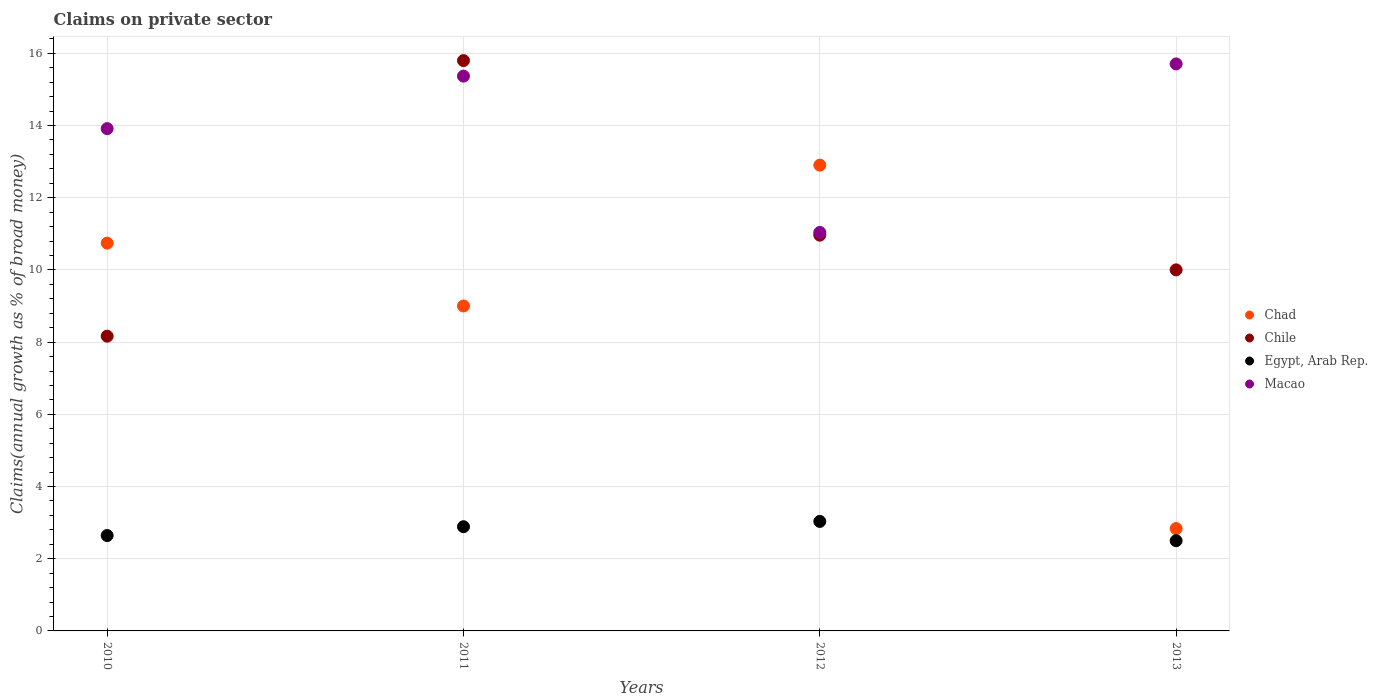Is the number of dotlines equal to the number of legend labels?
Make the answer very short. Yes. What is the percentage of broad money claimed on private sector in Chile in 2013?
Your answer should be compact. 10. Across all years, what is the maximum percentage of broad money claimed on private sector in Egypt, Arab Rep.?
Keep it short and to the point. 3.03. Across all years, what is the minimum percentage of broad money claimed on private sector in Egypt, Arab Rep.?
Your answer should be compact. 2.5. In which year was the percentage of broad money claimed on private sector in Chile maximum?
Provide a succinct answer. 2011. What is the total percentage of broad money claimed on private sector in Egypt, Arab Rep. in the graph?
Your response must be concise. 11.06. What is the difference between the percentage of broad money claimed on private sector in Macao in 2010 and that in 2013?
Ensure brevity in your answer.  -1.79. What is the difference between the percentage of broad money claimed on private sector in Chad in 2011 and the percentage of broad money claimed on private sector in Egypt, Arab Rep. in 2012?
Ensure brevity in your answer.  5.97. What is the average percentage of broad money claimed on private sector in Egypt, Arab Rep. per year?
Ensure brevity in your answer.  2.77. In the year 2013, what is the difference between the percentage of broad money claimed on private sector in Egypt, Arab Rep. and percentage of broad money claimed on private sector in Macao?
Your response must be concise. -13.21. In how many years, is the percentage of broad money claimed on private sector in Chile greater than 0.8 %?
Keep it short and to the point. 4. What is the ratio of the percentage of broad money claimed on private sector in Egypt, Arab Rep. in 2010 to that in 2011?
Your answer should be very brief. 0.92. What is the difference between the highest and the second highest percentage of broad money claimed on private sector in Egypt, Arab Rep.?
Offer a very short reply. 0.15. What is the difference between the highest and the lowest percentage of broad money claimed on private sector in Chile?
Make the answer very short. 7.63. In how many years, is the percentage of broad money claimed on private sector in Egypt, Arab Rep. greater than the average percentage of broad money claimed on private sector in Egypt, Arab Rep. taken over all years?
Offer a terse response. 2. Is it the case that in every year, the sum of the percentage of broad money claimed on private sector in Chad and percentage of broad money claimed on private sector in Macao  is greater than the sum of percentage of broad money claimed on private sector in Egypt, Arab Rep. and percentage of broad money claimed on private sector in Chile?
Offer a very short reply. No. Is the percentage of broad money claimed on private sector in Chile strictly greater than the percentage of broad money claimed on private sector in Egypt, Arab Rep. over the years?
Provide a short and direct response. Yes. Is the percentage of broad money claimed on private sector in Chad strictly less than the percentage of broad money claimed on private sector in Chile over the years?
Make the answer very short. No. How many dotlines are there?
Make the answer very short. 4. How many years are there in the graph?
Provide a short and direct response. 4. Are the values on the major ticks of Y-axis written in scientific E-notation?
Provide a short and direct response. No. How many legend labels are there?
Offer a very short reply. 4. How are the legend labels stacked?
Offer a terse response. Vertical. What is the title of the graph?
Your answer should be compact. Claims on private sector. Does "Comoros" appear as one of the legend labels in the graph?
Offer a terse response. No. What is the label or title of the X-axis?
Provide a short and direct response. Years. What is the label or title of the Y-axis?
Your response must be concise. Claims(annual growth as % of broad money). What is the Claims(annual growth as % of broad money) of Chad in 2010?
Offer a terse response. 10.74. What is the Claims(annual growth as % of broad money) of Chile in 2010?
Offer a very short reply. 8.16. What is the Claims(annual growth as % of broad money) in Egypt, Arab Rep. in 2010?
Offer a terse response. 2.64. What is the Claims(annual growth as % of broad money) in Macao in 2010?
Provide a short and direct response. 13.91. What is the Claims(annual growth as % of broad money) in Chad in 2011?
Offer a very short reply. 9. What is the Claims(annual growth as % of broad money) in Chile in 2011?
Ensure brevity in your answer.  15.8. What is the Claims(annual growth as % of broad money) of Egypt, Arab Rep. in 2011?
Your response must be concise. 2.89. What is the Claims(annual growth as % of broad money) in Macao in 2011?
Offer a terse response. 15.37. What is the Claims(annual growth as % of broad money) of Chad in 2012?
Your answer should be very brief. 12.9. What is the Claims(annual growth as % of broad money) in Chile in 2012?
Keep it short and to the point. 10.96. What is the Claims(annual growth as % of broad money) of Egypt, Arab Rep. in 2012?
Provide a short and direct response. 3.03. What is the Claims(annual growth as % of broad money) of Macao in 2012?
Provide a succinct answer. 11.04. What is the Claims(annual growth as % of broad money) of Chad in 2013?
Your answer should be compact. 2.84. What is the Claims(annual growth as % of broad money) in Chile in 2013?
Ensure brevity in your answer.  10. What is the Claims(annual growth as % of broad money) in Egypt, Arab Rep. in 2013?
Offer a very short reply. 2.5. What is the Claims(annual growth as % of broad money) of Macao in 2013?
Provide a short and direct response. 15.71. Across all years, what is the maximum Claims(annual growth as % of broad money) in Chad?
Provide a short and direct response. 12.9. Across all years, what is the maximum Claims(annual growth as % of broad money) of Chile?
Your answer should be very brief. 15.8. Across all years, what is the maximum Claims(annual growth as % of broad money) of Egypt, Arab Rep.?
Ensure brevity in your answer.  3.03. Across all years, what is the maximum Claims(annual growth as % of broad money) in Macao?
Provide a short and direct response. 15.71. Across all years, what is the minimum Claims(annual growth as % of broad money) in Chad?
Offer a very short reply. 2.84. Across all years, what is the minimum Claims(annual growth as % of broad money) in Chile?
Make the answer very short. 8.16. Across all years, what is the minimum Claims(annual growth as % of broad money) in Egypt, Arab Rep.?
Give a very brief answer. 2.5. Across all years, what is the minimum Claims(annual growth as % of broad money) in Macao?
Your response must be concise. 11.04. What is the total Claims(annual growth as % of broad money) of Chad in the graph?
Keep it short and to the point. 35.48. What is the total Claims(annual growth as % of broad money) of Chile in the graph?
Provide a succinct answer. 44.93. What is the total Claims(annual growth as % of broad money) in Egypt, Arab Rep. in the graph?
Provide a short and direct response. 11.06. What is the total Claims(annual growth as % of broad money) in Macao in the graph?
Ensure brevity in your answer.  56.03. What is the difference between the Claims(annual growth as % of broad money) of Chad in 2010 and that in 2011?
Your answer should be compact. 1.74. What is the difference between the Claims(annual growth as % of broad money) in Chile in 2010 and that in 2011?
Ensure brevity in your answer.  -7.63. What is the difference between the Claims(annual growth as % of broad money) of Egypt, Arab Rep. in 2010 and that in 2011?
Give a very brief answer. -0.24. What is the difference between the Claims(annual growth as % of broad money) of Macao in 2010 and that in 2011?
Ensure brevity in your answer.  -1.45. What is the difference between the Claims(annual growth as % of broad money) in Chad in 2010 and that in 2012?
Provide a short and direct response. -2.16. What is the difference between the Claims(annual growth as % of broad money) of Chile in 2010 and that in 2012?
Provide a short and direct response. -2.8. What is the difference between the Claims(annual growth as % of broad money) in Egypt, Arab Rep. in 2010 and that in 2012?
Provide a succinct answer. -0.39. What is the difference between the Claims(annual growth as % of broad money) in Macao in 2010 and that in 2012?
Your answer should be compact. 2.88. What is the difference between the Claims(annual growth as % of broad money) of Chad in 2010 and that in 2013?
Provide a short and direct response. 7.91. What is the difference between the Claims(annual growth as % of broad money) in Chile in 2010 and that in 2013?
Your answer should be compact. -1.84. What is the difference between the Claims(annual growth as % of broad money) in Egypt, Arab Rep. in 2010 and that in 2013?
Your answer should be compact. 0.14. What is the difference between the Claims(annual growth as % of broad money) in Macao in 2010 and that in 2013?
Offer a very short reply. -1.79. What is the difference between the Claims(annual growth as % of broad money) of Chad in 2011 and that in 2012?
Provide a short and direct response. -3.9. What is the difference between the Claims(annual growth as % of broad money) of Chile in 2011 and that in 2012?
Give a very brief answer. 4.84. What is the difference between the Claims(annual growth as % of broad money) of Egypt, Arab Rep. in 2011 and that in 2012?
Provide a short and direct response. -0.15. What is the difference between the Claims(annual growth as % of broad money) of Macao in 2011 and that in 2012?
Give a very brief answer. 4.33. What is the difference between the Claims(annual growth as % of broad money) in Chad in 2011 and that in 2013?
Offer a terse response. 6.17. What is the difference between the Claims(annual growth as % of broad money) in Chile in 2011 and that in 2013?
Your response must be concise. 5.8. What is the difference between the Claims(annual growth as % of broad money) in Egypt, Arab Rep. in 2011 and that in 2013?
Ensure brevity in your answer.  0.39. What is the difference between the Claims(annual growth as % of broad money) of Macao in 2011 and that in 2013?
Provide a short and direct response. -0.34. What is the difference between the Claims(annual growth as % of broad money) of Chad in 2012 and that in 2013?
Give a very brief answer. 10.07. What is the difference between the Claims(annual growth as % of broad money) of Chile in 2012 and that in 2013?
Offer a very short reply. 0.96. What is the difference between the Claims(annual growth as % of broad money) in Egypt, Arab Rep. in 2012 and that in 2013?
Your answer should be compact. 0.53. What is the difference between the Claims(annual growth as % of broad money) in Macao in 2012 and that in 2013?
Give a very brief answer. -4.67. What is the difference between the Claims(annual growth as % of broad money) in Chad in 2010 and the Claims(annual growth as % of broad money) in Chile in 2011?
Ensure brevity in your answer.  -5.06. What is the difference between the Claims(annual growth as % of broad money) of Chad in 2010 and the Claims(annual growth as % of broad money) of Egypt, Arab Rep. in 2011?
Your response must be concise. 7.86. What is the difference between the Claims(annual growth as % of broad money) in Chad in 2010 and the Claims(annual growth as % of broad money) in Macao in 2011?
Your answer should be very brief. -4.63. What is the difference between the Claims(annual growth as % of broad money) of Chile in 2010 and the Claims(annual growth as % of broad money) of Egypt, Arab Rep. in 2011?
Offer a terse response. 5.28. What is the difference between the Claims(annual growth as % of broad money) in Chile in 2010 and the Claims(annual growth as % of broad money) in Macao in 2011?
Your answer should be very brief. -7.2. What is the difference between the Claims(annual growth as % of broad money) of Egypt, Arab Rep. in 2010 and the Claims(annual growth as % of broad money) of Macao in 2011?
Your answer should be compact. -12.73. What is the difference between the Claims(annual growth as % of broad money) in Chad in 2010 and the Claims(annual growth as % of broad money) in Chile in 2012?
Give a very brief answer. -0.22. What is the difference between the Claims(annual growth as % of broad money) in Chad in 2010 and the Claims(annual growth as % of broad money) in Egypt, Arab Rep. in 2012?
Your answer should be compact. 7.71. What is the difference between the Claims(annual growth as % of broad money) of Chad in 2010 and the Claims(annual growth as % of broad money) of Macao in 2012?
Provide a short and direct response. -0.3. What is the difference between the Claims(annual growth as % of broad money) in Chile in 2010 and the Claims(annual growth as % of broad money) in Egypt, Arab Rep. in 2012?
Offer a very short reply. 5.13. What is the difference between the Claims(annual growth as % of broad money) in Chile in 2010 and the Claims(annual growth as % of broad money) in Macao in 2012?
Offer a very short reply. -2.87. What is the difference between the Claims(annual growth as % of broad money) in Egypt, Arab Rep. in 2010 and the Claims(annual growth as % of broad money) in Macao in 2012?
Provide a short and direct response. -8.4. What is the difference between the Claims(annual growth as % of broad money) of Chad in 2010 and the Claims(annual growth as % of broad money) of Chile in 2013?
Keep it short and to the point. 0.74. What is the difference between the Claims(annual growth as % of broad money) in Chad in 2010 and the Claims(annual growth as % of broad money) in Egypt, Arab Rep. in 2013?
Keep it short and to the point. 8.24. What is the difference between the Claims(annual growth as % of broad money) in Chad in 2010 and the Claims(annual growth as % of broad money) in Macao in 2013?
Keep it short and to the point. -4.96. What is the difference between the Claims(annual growth as % of broad money) of Chile in 2010 and the Claims(annual growth as % of broad money) of Egypt, Arab Rep. in 2013?
Keep it short and to the point. 5.67. What is the difference between the Claims(annual growth as % of broad money) of Chile in 2010 and the Claims(annual growth as % of broad money) of Macao in 2013?
Offer a terse response. -7.54. What is the difference between the Claims(annual growth as % of broad money) in Egypt, Arab Rep. in 2010 and the Claims(annual growth as % of broad money) in Macao in 2013?
Your answer should be very brief. -13.06. What is the difference between the Claims(annual growth as % of broad money) of Chad in 2011 and the Claims(annual growth as % of broad money) of Chile in 2012?
Offer a terse response. -1.96. What is the difference between the Claims(annual growth as % of broad money) in Chad in 2011 and the Claims(annual growth as % of broad money) in Egypt, Arab Rep. in 2012?
Make the answer very short. 5.97. What is the difference between the Claims(annual growth as % of broad money) in Chad in 2011 and the Claims(annual growth as % of broad money) in Macao in 2012?
Your response must be concise. -2.04. What is the difference between the Claims(annual growth as % of broad money) in Chile in 2011 and the Claims(annual growth as % of broad money) in Egypt, Arab Rep. in 2012?
Offer a terse response. 12.77. What is the difference between the Claims(annual growth as % of broad money) of Chile in 2011 and the Claims(annual growth as % of broad money) of Macao in 2012?
Give a very brief answer. 4.76. What is the difference between the Claims(annual growth as % of broad money) of Egypt, Arab Rep. in 2011 and the Claims(annual growth as % of broad money) of Macao in 2012?
Offer a terse response. -8.15. What is the difference between the Claims(annual growth as % of broad money) of Chad in 2011 and the Claims(annual growth as % of broad money) of Chile in 2013?
Your answer should be very brief. -1. What is the difference between the Claims(annual growth as % of broad money) in Chad in 2011 and the Claims(annual growth as % of broad money) in Egypt, Arab Rep. in 2013?
Provide a succinct answer. 6.5. What is the difference between the Claims(annual growth as % of broad money) in Chad in 2011 and the Claims(annual growth as % of broad money) in Macao in 2013?
Keep it short and to the point. -6.71. What is the difference between the Claims(annual growth as % of broad money) in Chile in 2011 and the Claims(annual growth as % of broad money) in Egypt, Arab Rep. in 2013?
Make the answer very short. 13.3. What is the difference between the Claims(annual growth as % of broad money) in Chile in 2011 and the Claims(annual growth as % of broad money) in Macao in 2013?
Your answer should be compact. 0.09. What is the difference between the Claims(annual growth as % of broad money) in Egypt, Arab Rep. in 2011 and the Claims(annual growth as % of broad money) in Macao in 2013?
Keep it short and to the point. -12.82. What is the difference between the Claims(annual growth as % of broad money) of Chad in 2012 and the Claims(annual growth as % of broad money) of Chile in 2013?
Your answer should be very brief. 2.9. What is the difference between the Claims(annual growth as % of broad money) in Chad in 2012 and the Claims(annual growth as % of broad money) in Egypt, Arab Rep. in 2013?
Keep it short and to the point. 10.4. What is the difference between the Claims(annual growth as % of broad money) in Chad in 2012 and the Claims(annual growth as % of broad money) in Macao in 2013?
Make the answer very short. -2.8. What is the difference between the Claims(annual growth as % of broad money) in Chile in 2012 and the Claims(annual growth as % of broad money) in Egypt, Arab Rep. in 2013?
Your answer should be compact. 8.46. What is the difference between the Claims(annual growth as % of broad money) of Chile in 2012 and the Claims(annual growth as % of broad money) of Macao in 2013?
Ensure brevity in your answer.  -4.74. What is the difference between the Claims(annual growth as % of broad money) in Egypt, Arab Rep. in 2012 and the Claims(annual growth as % of broad money) in Macao in 2013?
Offer a very short reply. -12.67. What is the average Claims(annual growth as % of broad money) in Chad per year?
Provide a succinct answer. 8.87. What is the average Claims(annual growth as % of broad money) of Chile per year?
Ensure brevity in your answer.  11.23. What is the average Claims(annual growth as % of broad money) of Egypt, Arab Rep. per year?
Ensure brevity in your answer.  2.77. What is the average Claims(annual growth as % of broad money) in Macao per year?
Your answer should be compact. 14.01. In the year 2010, what is the difference between the Claims(annual growth as % of broad money) in Chad and Claims(annual growth as % of broad money) in Chile?
Provide a short and direct response. 2.58. In the year 2010, what is the difference between the Claims(annual growth as % of broad money) in Chad and Claims(annual growth as % of broad money) in Egypt, Arab Rep.?
Your answer should be very brief. 8.1. In the year 2010, what is the difference between the Claims(annual growth as % of broad money) of Chad and Claims(annual growth as % of broad money) of Macao?
Provide a succinct answer. -3.17. In the year 2010, what is the difference between the Claims(annual growth as % of broad money) in Chile and Claims(annual growth as % of broad money) in Egypt, Arab Rep.?
Offer a very short reply. 5.52. In the year 2010, what is the difference between the Claims(annual growth as % of broad money) of Chile and Claims(annual growth as % of broad money) of Macao?
Provide a succinct answer. -5.75. In the year 2010, what is the difference between the Claims(annual growth as % of broad money) of Egypt, Arab Rep. and Claims(annual growth as % of broad money) of Macao?
Provide a short and direct response. -11.27. In the year 2011, what is the difference between the Claims(annual growth as % of broad money) in Chad and Claims(annual growth as % of broad money) in Chile?
Your answer should be very brief. -6.8. In the year 2011, what is the difference between the Claims(annual growth as % of broad money) in Chad and Claims(annual growth as % of broad money) in Egypt, Arab Rep.?
Your answer should be very brief. 6.11. In the year 2011, what is the difference between the Claims(annual growth as % of broad money) of Chad and Claims(annual growth as % of broad money) of Macao?
Provide a short and direct response. -6.37. In the year 2011, what is the difference between the Claims(annual growth as % of broad money) of Chile and Claims(annual growth as % of broad money) of Egypt, Arab Rep.?
Make the answer very short. 12.91. In the year 2011, what is the difference between the Claims(annual growth as % of broad money) in Chile and Claims(annual growth as % of broad money) in Macao?
Offer a terse response. 0.43. In the year 2011, what is the difference between the Claims(annual growth as % of broad money) of Egypt, Arab Rep. and Claims(annual growth as % of broad money) of Macao?
Keep it short and to the point. -12.48. In the year 2012, what is the difference between the Claims(annual growth as % of broad money) in Chad and Claims(annual growth as % of broad money) in Chile?
Provide a succinct answer. 1.94. In the year 2012, what is the difference between the Claims(annual growth as % of broad money) in Chad and Claims(annual growth as % of broad money) in Egypt, Arab Rep.?
Your answer should be very brief. 9.87. In the year 2012, what is the difference between the Claims(annual growth as % of broad money) in Chad and Claims(annual growth as % of broad money) in Macao?
Keep it short and to the point. 1.86. In the year 2012, what is the difference between the Claims(annual growth as % of broad money) of Chile and Claims(annual growth as % of broad money) of Egypt, Arab Rep.?
Provide a succinct answer. 7.93. In the year 2012, what is the difference between the Claims(annual growth as % of broad money) in Chile and Claims(annual growth as % of broad money) in Macao?
Your answer should be compact. -0.08. In the year 2012, what is the difference between the Claims(annual growth as % of broad money) of Egypt, Arab Rep. and Claims(annual growth as % of broad money) of Macao?
Your response must be concise. -8.01. In the year 2013, what is the difference between the Claims(annual growth as % of broad money) of Chad and Claims(annual growth as % of broad money) of Chile?
Your response must be concise. -7.17. In the year 2013, what is the difference between the Claims(annual growth as % of broad money) in Chad and Claims(annual growth as % of broad money) in Egypt, Arab Rep.?
Offer a very short reply. 0.34. In the year 2013, what is the difference between the Claims(annual growth as % of broad money) of Chad and Claims(annual growth as % of broad money) of Macao?
Offer a terse response. -12.87. In the year 2013, what is the difference between the Claims(annual growth as % of broad money) in Chile and Claims(annual growth as % of broad money) in Egypt, Arab Rep.?
Give a very brief answer. 7.5. In the year 2013, what is the difference between the Claims(annual growth as % of broad money) in Chile and Claims(annual growth as % of broad money) in Macao?
Give a very brief answer. -5.71. In the year 2013, what is the difference between the Claims(annual growth as % of broad money) in Egypt, Arab Rep. and Claims(annual growth as % of broad money) in Macao?
Offer a very short reply. -13.21. What is the ratio of the Claims(annual growth as % of broad money) of Chad in 2010 to that in 2011?
Offer a terse response. 1.19. What is the ratio of the Claims(annual growth as % of broad money) of Chile in 2010 to that in 2011?
Offer a very short reply. 0.52. What is the ratio of the Claims(annual growth as % of broad money) in Egypt, Arab Rep. in 2010 to that in 2011?
Give a very brief answer. 0.92. What is the ratio of the Claims(annual growth as % of broad money) in Macao in 2010 to that in 2011?
Offer a terse response. 0.91. What is the ratio of the Claims(annual growth as % of broad money) in Chad in 2010 to that in 2012?
Offer a very short reply. 0.83. What is the ratio of the Claims(annual growth as % of broad money) in Chile in 2010 to that in 2012?
Your response must be concise. 0.74. What is the ratio of the Claims(annual growth as % of broad money) of Egypt, Arab Rep. in 2010 to that in 2012?
Your answer should be compact. 0.87. What is the ratio of the Claims(annual growth as % of broad money) in Macao in 2010 to that in 2012?
Offer a very short reply. 1.26. What is the ratio of the Claims(annual growth as % of broad money) in Chad in 2010 to that in 2013?
Provide a succinct answer. 3.79. What is the ratio of the Claims(annual growth as % of broad money) in Chile in 2010 to that in 2013?
Provide a succinct answer. 0.82. What is the ratio of the Claims(annual growth as % of broad money) of Egypt, Arab Rep. in 2010 to that in 2013?
Your response must be concise. 1.06. What is the ratio of the Claims(annual growth as % of broad money) in Macao in 2010 to that in 2013?
Keep it short and to the point. 0.89. What is the ratio of the Claims(annual growth as % of broad money) in Chad in 2011 to that in 2012?
Ensure brevity in your answer.  0.7. What is the ratio of the Claims(annual growth as % of broad money) in Chile in 2011 to that in 2012?
Offer a very short reply. 1.44. What is the ratio of the Claims(annual growth as % of broad money) of Egypt, Arab Rep. in 2011 to that in 2012?
Provide a short and direct response. 0.95. What is the ratio of the Claims(annual growth as % of broad money) of Macao in 2011 to that in 2012?
Your answer should be compact. 1.39. What is the ratio of the Claims(annual growth as % of broad money) of Chad in 2011 to that in 2013?
Provide a succinct answer. 3.17. What is the ratio of the Claims(annual growth as % of broad money) of Chile in 2011 to that in 2013?
Provide a succinct answer. 1.58. What is the ratio of the Claims(annual growth as % of broad money) of Egypt, Arab Rep. in 2011 to that in 2013?
Provide a succinct answer. 1.16. What is the ratio of the Claims(annual growth as % of broad money) of Macao in 2011 to that in 2013?
Provide a short and direct response. 0.98. What is the ratio of the Claims(annual growth as % of broad money) in Chad in 2012 to that in 2013?
Your response must be concise. 4.55. What is the ratio of the Claims(annual growth as % of broad money) in Chile in 2012 to that in 2013?
Provide a succinct answer. 1.1. What is the ratio of the Claims(annual growth as % of broad money) of Egypt, Arab Rep. in 2012 to that in 2013?
Make the answer very short. 1.21. What is the ratio of the Claims(annual growth as % of broad money) in Macao in 2012 to that in 2013?
Ensure brevity in your answer.  0.7. What is the difference between the highest and the second highest Claims(annual growth as % of broad money) of Chad?
Provide a succinct answer. 2.16. What is the difference between the highest and the second highest Claims(annual growth as % of broad money) in Chile?
Offer a terse response. 4.84. What is the difference between the highest and the second highest Claims(annual growth as % of broad money) of Egypt, Arab Rep.?
Provide a succinct answer. 0.15. What is the difference between the highest and the second highest Claims(annual growth as % of broad money) of Macao?
Your answer should be very brief. 0.34. What is the difference between the highest and the lowest Claims(annual growth as % of broad money) in Chad?
Keep it short and to the point. 10.07. What is the difference between the highest and the lowest Claims(annual growth as % of broad money) in Chile?
Make the answer very short. 7.63. What is the difference between the highest and the lowest Claims(annual growth as % of broad money) of Egypt, Arab Rep.?
Offer a very short reply. 0.53. What is the difference between the highest and the lowest Claims(annual growth as % of broad money) in Macao?
Your answer should be very brief. 4.67. 